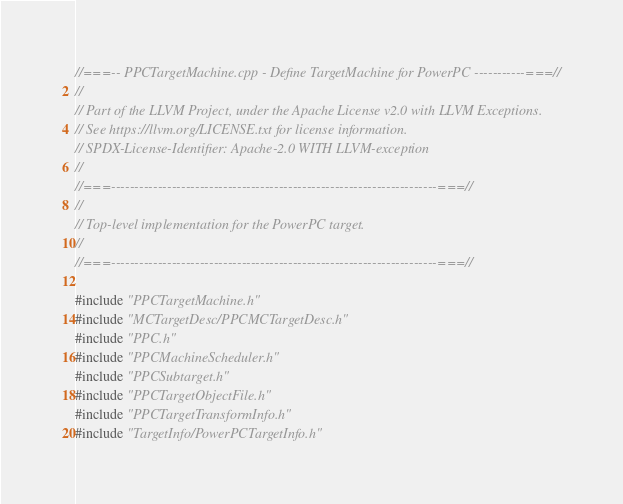<code> <loc_0><loc_0><loc_500><loc_500><_C++_>//===-- PPCTargetMachine.cpp - Define TargetMachine for PowerPC -----------===//
//
// Part of the LLVM Project, under the Apache License v2.0 with LLVM Exceptions.
// See https://llvm.org/LICENSE.txt for license information.
// SPDX-License-Identifier: Apache-2.0 WITH LLVM-exception
//
//===----------------------------------------------------------------------===//
//
// Top-level implementation for the PowerPC target.
//
//===----------------------------------------------------------------------===//

#include "PPCTargetMachine.h"
#include "MCTargetDesc/PPCMCTargetDesc.h"
#include "PPC.h"
#include "PPCMachineScheduler.h"
#include "PPCSubtarget.h"
#include "PPCTargetObjectFile.h"
#include "PPCTargetTransformInfo.h"
#include "TargetInfo/PowerPCTargetInfo.h"</code> 